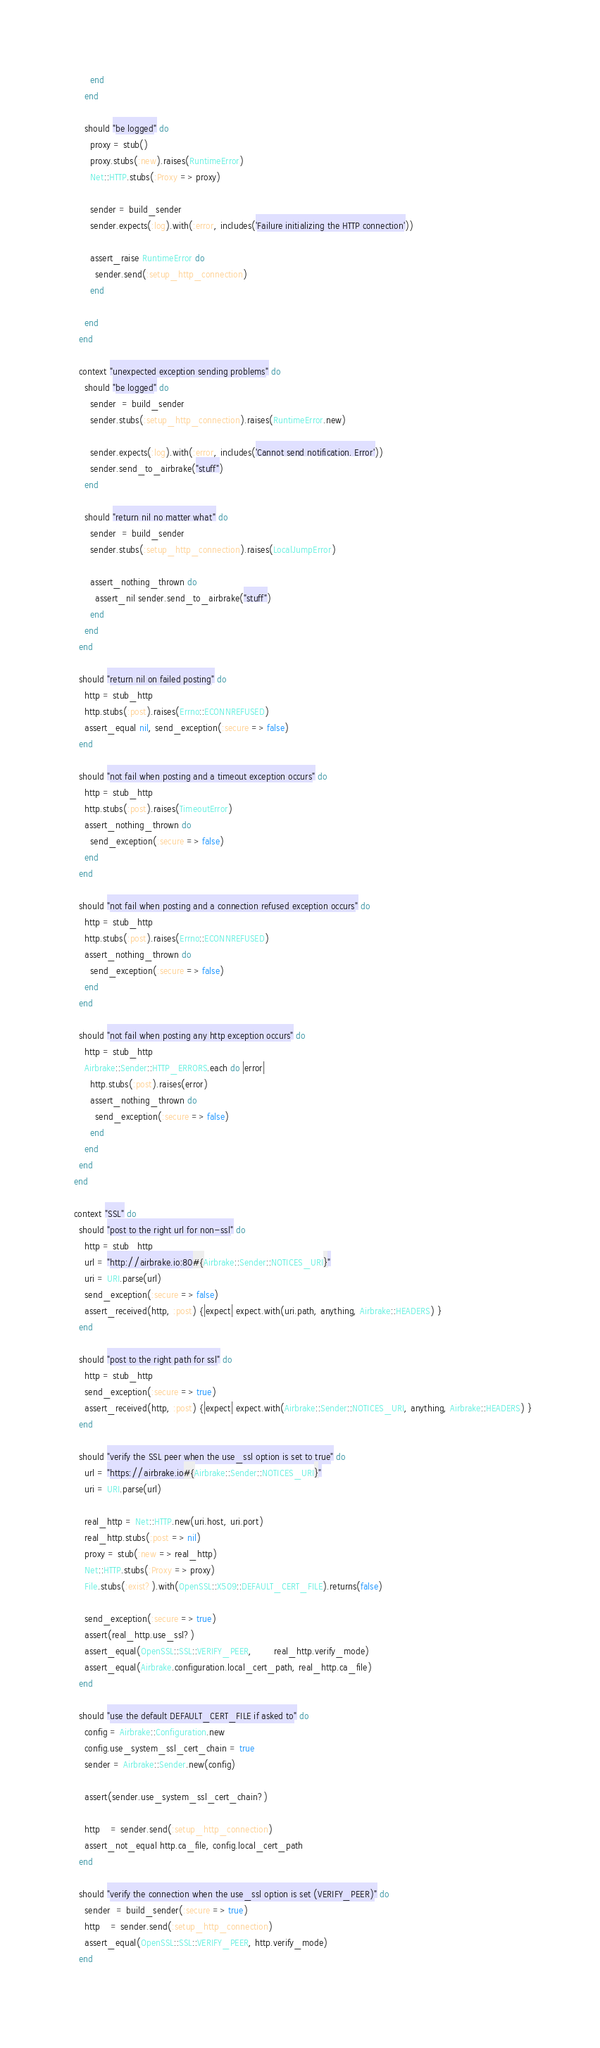<code> <loc_0><loc_0><loc_500><loc_500><_Ruby_>        end
      end
      
      should "be logged" do
        proxy = stub()
        proxy.stubs(:new).raises(RuntimeError)
        Net::HTTP.stubs(:Proxy => proxy)
        
        sender = build_sender
        sender.expects(:log).with(:error, includes('Failure initializing the HTTP connection'))

        assert_raise RuntimeError do
          sender.send(:setup_http_connection)
        end

      end
    end
    
    context "unexpected exception sending problems" do
      should "be logged" do
        sender  = build_sender
        sender.stubs(:setup_http_connection).raises(RuntimeError.new)
        
        sender.expects(:log).with(:error, includes('Cannot send notification. Error'))
        sender.send_to_airbrake("stuff")
      end
      
      should "return nil no matter what" do
        sender  = build_sender
        sender.stubs(:setup_http_connection).raises(LocalJumpError)
        
        assert_nothing_thrown do
          assert_nil sender.send_to_airbrake("stuff")
        end
      end
    end
    
    should "return nil on failed posting" do
      http = stub_http
      http.stubs(:post).raises(Errno::ECONNREFUSED)
      assert_equal nil, send_exception(:secure => false)
    end

    should "not fail when posting and a timeout exception occurs" do
      http = stub_http
      http.stubs(:post).raises(TimeoutError)
      assert_nothing_thrown do
        send_exception(:secure => false)
      end
    end

    should "not fail when posting and a connection refused exception occurs" do
      http = stub_http
      http.stubs(:post).raises(Errno::ECONNREFUSED)
      assert_nothing_thrown do
        send_exception(:secure => false)
      end
    end

    should "not fail when posting any http exception occurs" do
      http = stub_http
      Airbrake::Sender::HTTP_ERRORS.each do |error|
        http.stubs(:post).raises(error)
        assert_nothing_thrown do
          send_exception(:secure => false)
        end
      end
    end
  end

  context "SSL" do
    should "post to the right url for non-ssl" do
      http = stub_http
      url = "http://airbrake.io:80#{Airbrake::Sender::NOTICES_URI}"
      uri = URI.parse(url)
      send_exception(:secure => false)
      assert_received(http, :post) {|expect| expect.with(uri.path, anything, Airbrake::HEADERS) }
    end

    should "post to the right path for ssl" do
      http = stub_http
      send_exception(:secure => true)
      assert_received(http, :post) {|expect| expect.with(Airbrake::Sender::NOTICES_URI, anything, Airbrake::HEADERS) }
    end

    should "verify the SSL peer when the use_ssl option is set to true" do
      url = "https://airbrake.io#{Airbrake::Sender::NOTICES_URI}"
      uri = URI.parse(url)

      real_http = Net::HTTP.new(uri.host, uri.port)
      real_http.stubs(:post => nil)
      proxy = stub(:new => real_http)
      Net::HTTP.stubs(:Proxy => proxy)
      File.stubs(:exist?).with(OpenSSL::X509::DEFAULT_CERT_FILE).returns(false)

      send_exception(:secure => true)
      assert(real_http.use_ssl?)
      assert_equal(OpenSSL::SSL::VERIFY_PEER,        real_http.verify_mode)
      assert_equal(Airbrake.configuration.local_cert_path, real_http.ca_file)
    end
    
    should "use the default DEFAULT_CERT_FILE if asked to" do
      config = Airbrake::Configuration.new
      config.use_system_ssl_cert_chain = true
      sender = Airbrake::Sender.new(config)

      assert(sender.use_system_ssl_cert_chain?)

      http    = sender.send(:setup_http_connection)
      assert_not_equal http.ca_file, config.local_cert_path
    end
    
    should "verify the connection when the use_ssl option is set (VERIFY_PEER)" do
      sender  = build_sender(:secure => true)
      http    = sender.send(:setup_http_connection)
      assert_equal(OpenSSL::SSL::VERIFY_PEER, http.verify_mode)
    end
    </code> 